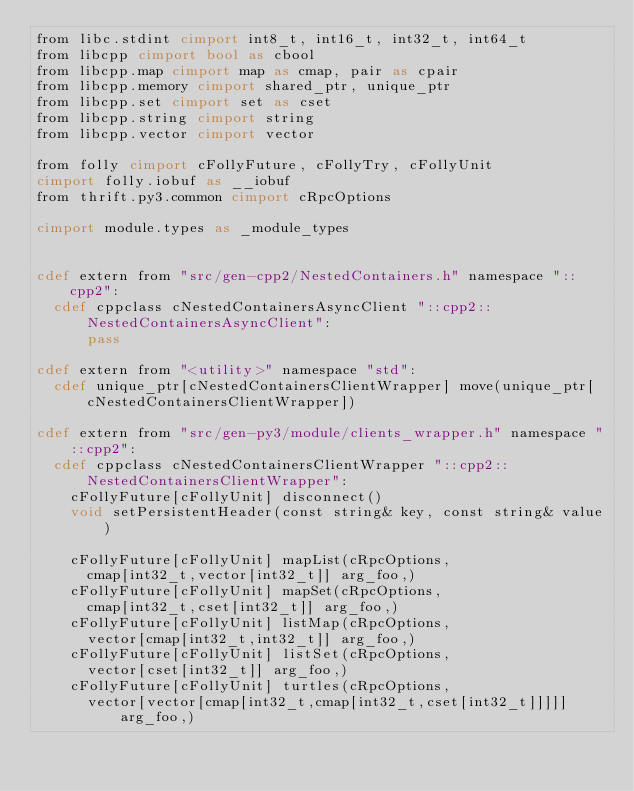Convert code to text. <code><loc_0><loc_0><loc_500><loc_500><_Cython_>from libc.stdint cimport int8_t, int16_t, int32_t, int64_t
from libcpp cimport bool as cbool
from libcpp.map cimport map as cmap, pair as cpair
from libcpp.memory cimport shared_ptr, unique_ptr
from libcpp.set cimport set as cset
from libcpp.string cimport string
from libcpp.vector cimport vector

from folly cimport cFollyFuture, cFollyTry, cFollyUnit
cimport folly.iobuf as __iobuf
from thrift.py3.common cimport cRpcOptions

cimport module.types as _module_types


cdef extern from "src/gen-cpp2/NestedContainers.h" namespace "::cpp2":
  cdef cppclass cNestedContainersAsyncClient "::cpp2::NestedContainersAsyncClient":
      pass

cdef extern from "<utility>" namespace "std":
  cdef unique_ptr[cNestedContainersClientWrapper] move(unique_ptr[cNestedContainersClientWrapper])

cdef extern from "src/gen-py3/module/clients_wrapper.h" namespace "::cpp2":
  cdef cppclass cNestedContainersClientWrapper "::cpp2::NestedContainersClientWrapper":
    cFollyFuture[cFollyUnit] disconnect()
    void setPersistentHeader(const string& key, const string& value)

    cFollyFuture[cFollyUnit] mapList(cRpcOptions, 
      cmap[int32_t,vector[int32_t]] arg_foo,)
    cFollyFuture[cFollyUnit] mapSet(cRpcOptions, 
      cmap[int32_t,cset[int32_t]] arg_foo,)
    cFollyFuture[cFollyUnit] listMap(cRpcOptions, 
      vector[cmap[int32_t,int32_t]] arg_foo,)
    cFollyFuture[cFollyUnit] listSet(cRpcOptions, 
      vector[cset[int32_t]] arg_foo,)
    cFollyFuture[cFollyUnit] turtles(cRpcOptions, 
      vector[vector[cmap[int32_t,cmap[int32_t,cset[int32_t]]]]] arg_foo,)

</code> 